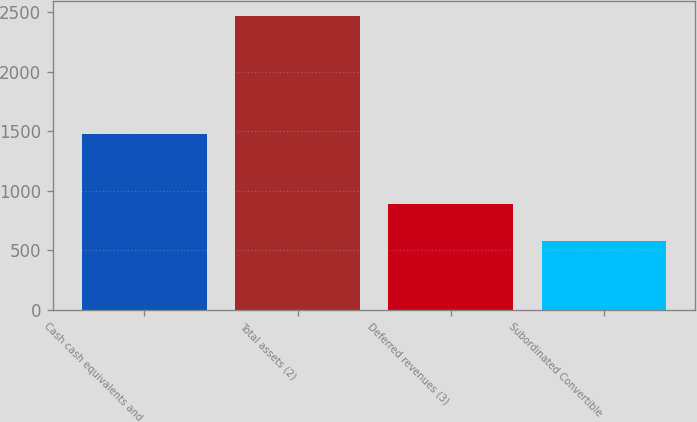Convert chart. <chart><loc_0><loc_0><loc_500><loc_500><bar_chart><fcel>Cash cash equivalents and<fcel>Total assets (2)<fcel>Deferred revenues (3)<fcel>Subordinated Convertible<nl><fcel>1477<fcel>2470<fcel>888<fcel>574<nl></chart> 